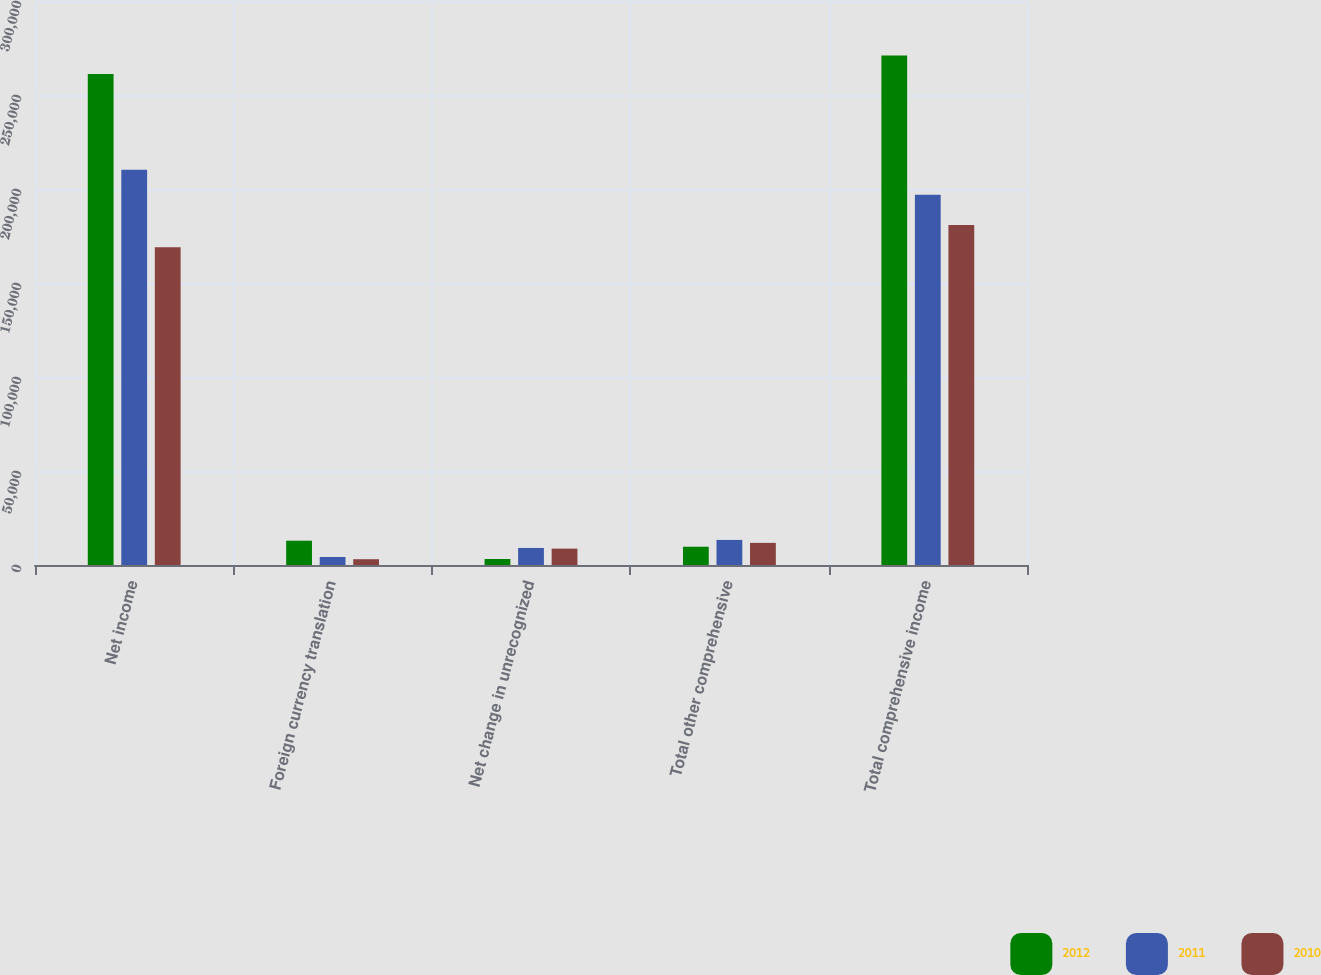Convert chart. <chart><loc_0><loc_0><loc_500><loc_500><stacked_bar_chart><ecel><fcel>Net income<fcel>Foreign currency translation<fcel>Net change in unrecognized<fcel>Total other comprehensive<fcel>Total comprehensive income<nl><fcel>2012<fcel>261225<fcel>12921<fcel>3201<fcel>9720<fcel>270945<nl><fcel>2011<fcel>210264<fcel>4273<fcel>9066<fcel>13339<fcel>196925<nl><fcel>2010<fcel>169071<fcel>3078<fcel>8712<fcel>11775<fcel>180846<nl></chart> 